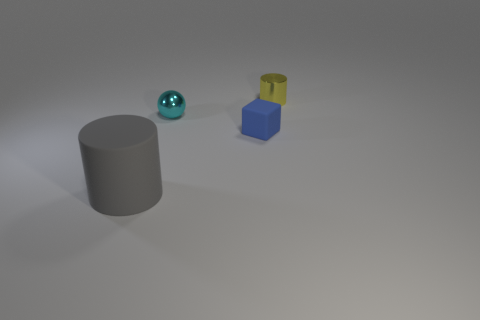What could the colors and shapes of the objects tell us about their possible functions? The colors and shapes of the objects might hint at a utilitarian grouping where each item has a specific purpose. The grey cylinder could be a container or a support structure. The reflective metal sphere might be a sort of observational device or ornament, given its polished appearance. The blue cube seems sturdy and functional, possibly a building block for a larger assembly, while the yellow cylinder on top could be a cap or a modifier indicating a status or level. 